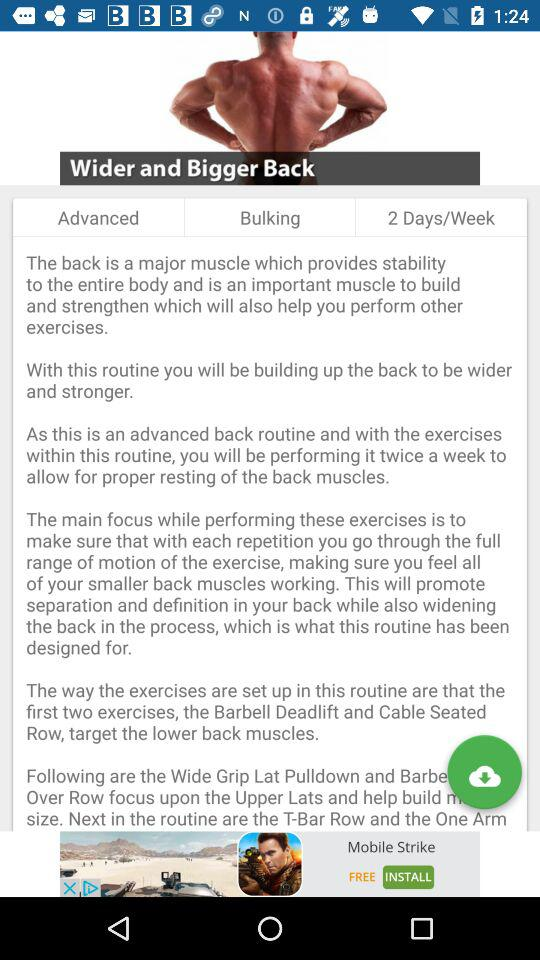How many days in a week should we do back exercises? You should do back exercises 2 days a week. 